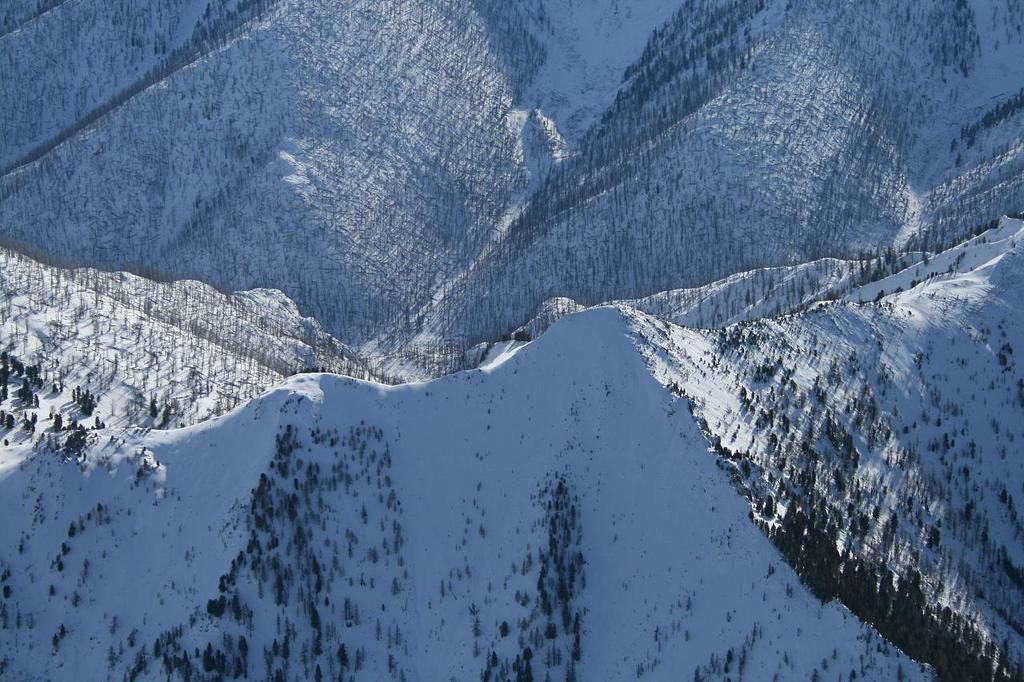Could you give a brief overview of what you see in this image? At the bottom of this image, there are mountains having trees. In the background, there are other snow mountains. 